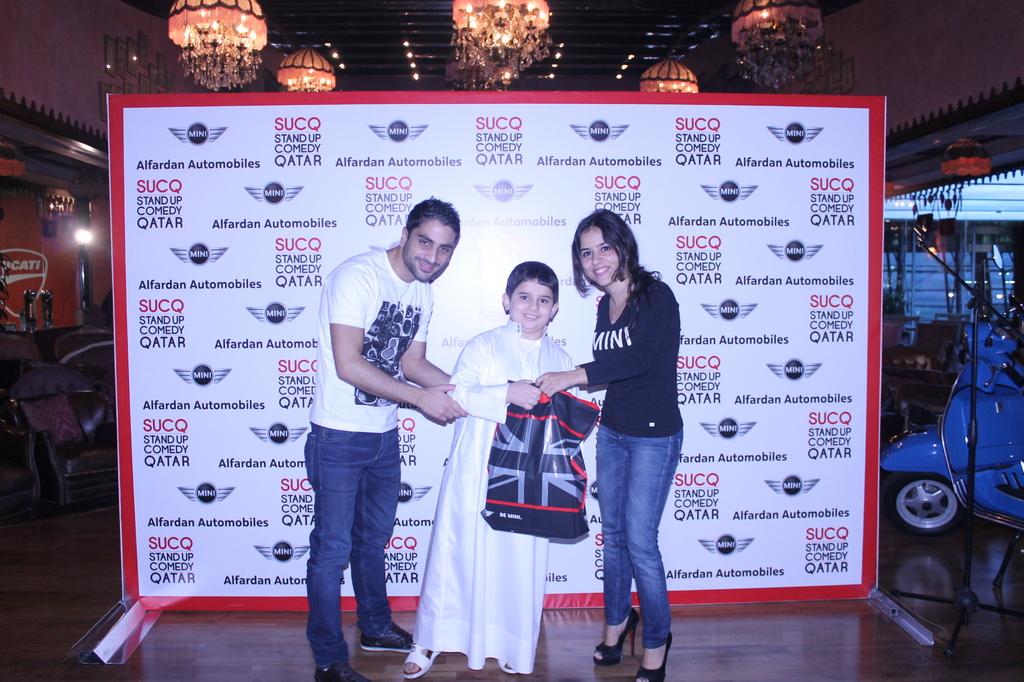What word is on the ladies shirt?
Your answer should be compact. Mini. 